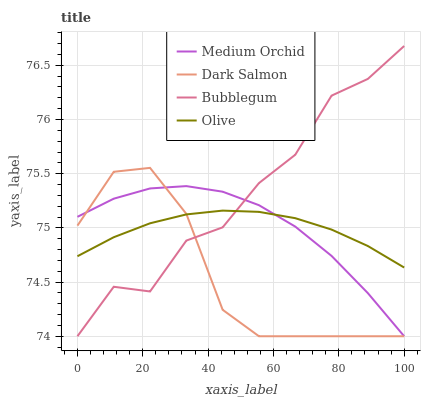Does Dark Salmon have the minimum area under the curve?
Answer yes or no. Yes. Does Bubblegum have the maximum area under the curve?
Answer yes or no. Yes. Does Medium Orchid have the minimum area under the curve?
Answer yes or no. No. Does Medium Orchid have the maximum area under the curve?
Answer yes or no. No. Is Olive the smoothest?
Answer yes or no. Yes. Is Bubblegum the roughest?
Answer yes or no. Yes. Is Medium Orchid the smoothest?
Answer yes or no. No. Is Medium Orchid the roughest?
Answer yes or no. No. Does Medium Orchid have the lowest value?
Answer yes or no. Yes. Does Bubblegum have the highest value?
Answer yes or no. Yes. Does Medium Orchid have the highest value?
Answer yes or no. No. Does Dark Salmon intersect Medium Orchid?
Answer yes or no. Yes. Is Dark Salmon less than Medium Orchid?
Answer yes or no. No. Is Dark Salmon greater than Medium Orchid?
Answer yes or no. No. 